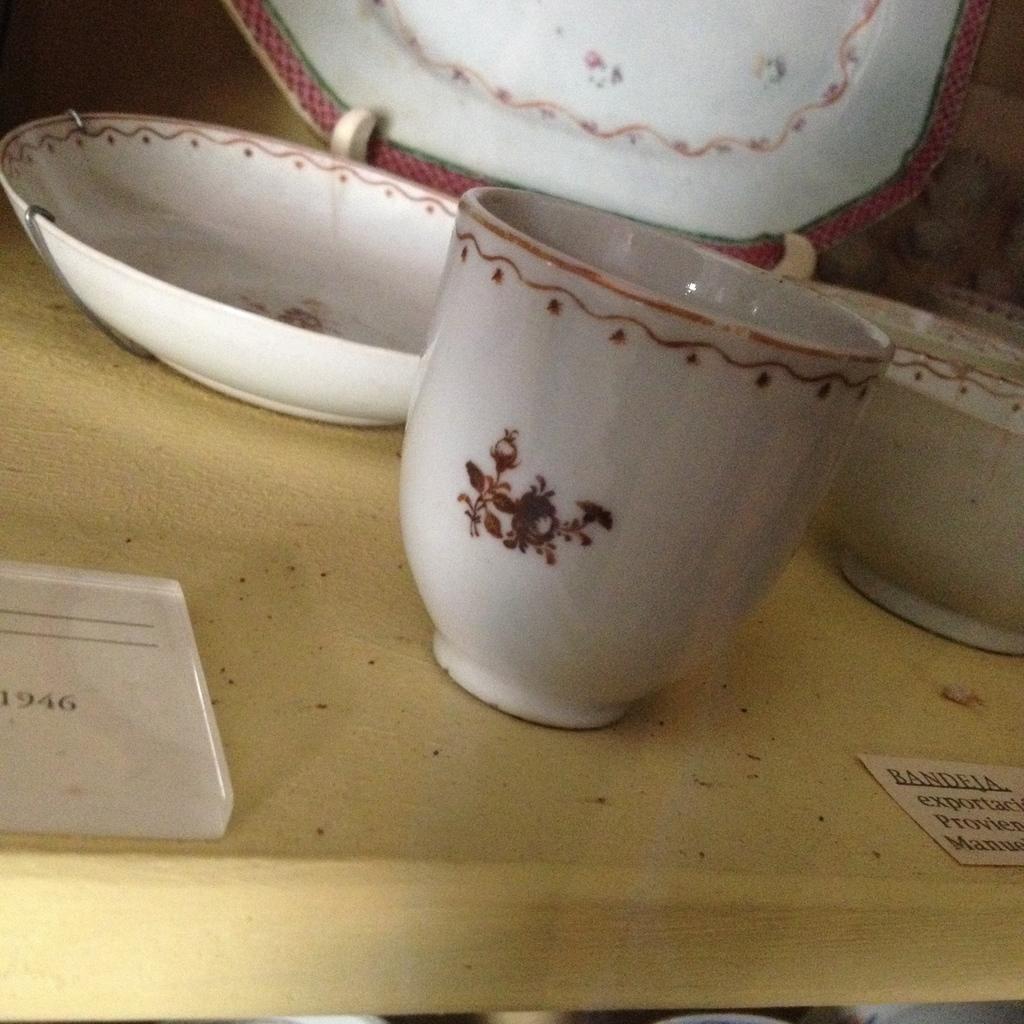How would you summarize this image in a sentence or two? In this picture, we see a wooden table on which a plate, cup and the bowls are placed. On the left side, we see a board with the numbers written on it. On the right side, we see a card with some text written on it. 